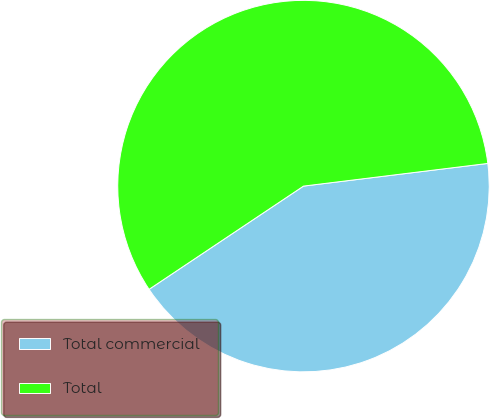Convert chart. <chart><loc_0><loc_0><loc_500><loc_500><pie_chart><fcel>Total commercial<fcel>Total<nl><fcel>42.57%<fcel>57.43%<nl></chart> 